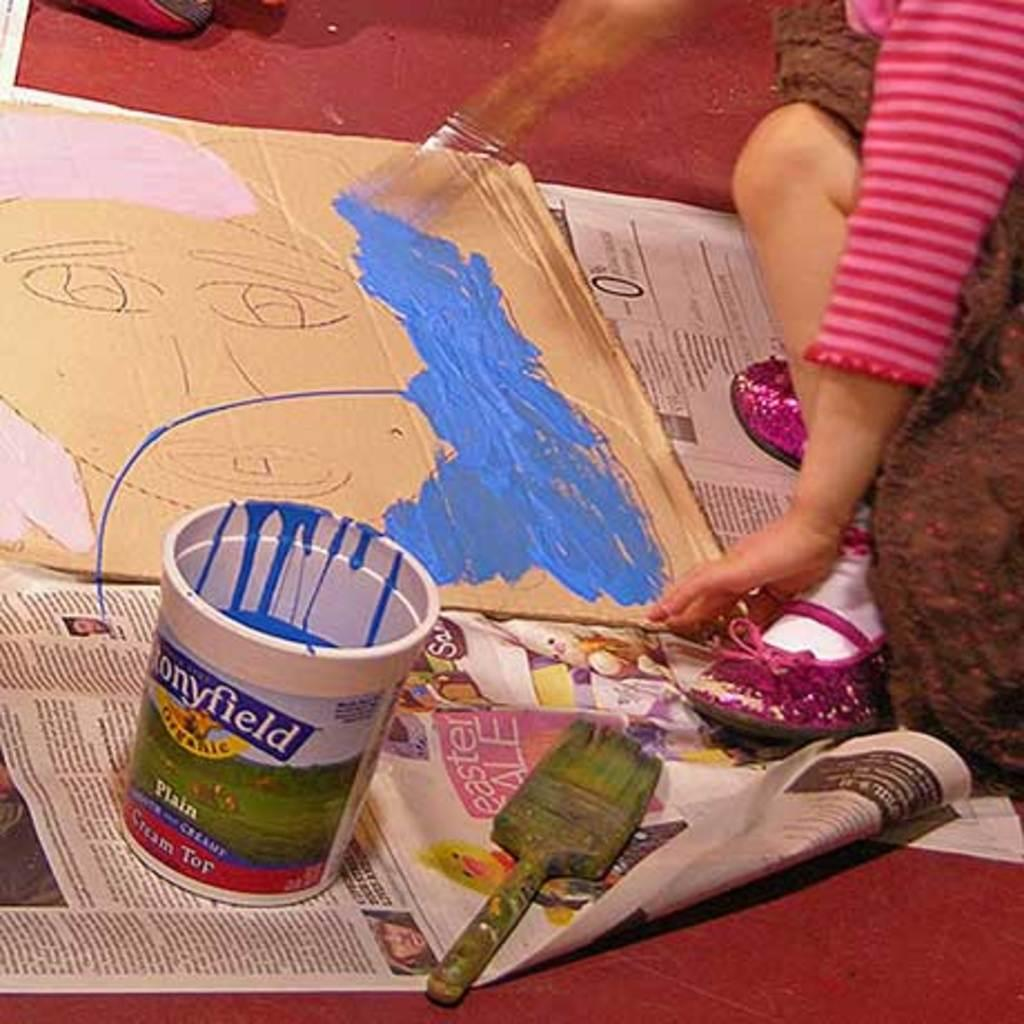What is in the paint box that is visible in the image? There is a paint box with paint in the image. What tool is used for applying paint in the image? There is a paint brush in the image. What surface is the cardboard sheet placed on in the image? The cardboard sheet is on a newspaper in the image. Where is the newspaper located in the image? The newspaper is on the floor in the image. Who is present in the image? There is a person in the image. How many brothers does the person in the image have? There is no information about the person's brothers in the image. What is the person in the image doing when they suddenly sneeze? There is no indication of the person sneezing in the image. 